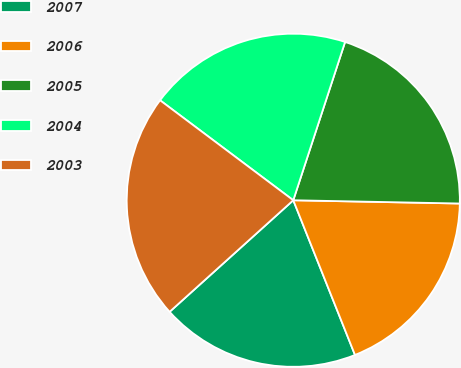Convert chart. <chart><loc_0><loc_0><loc_500><loc_500><pie_chart><fcel>2007<fcel>2006<fcel>2005<fcel>2004<fcel>2003<nl><fcel>19.36%<fcel>18.65%<fcel>20.28%<fcel>19.79%<fcel>21.93%<nl></chart> 